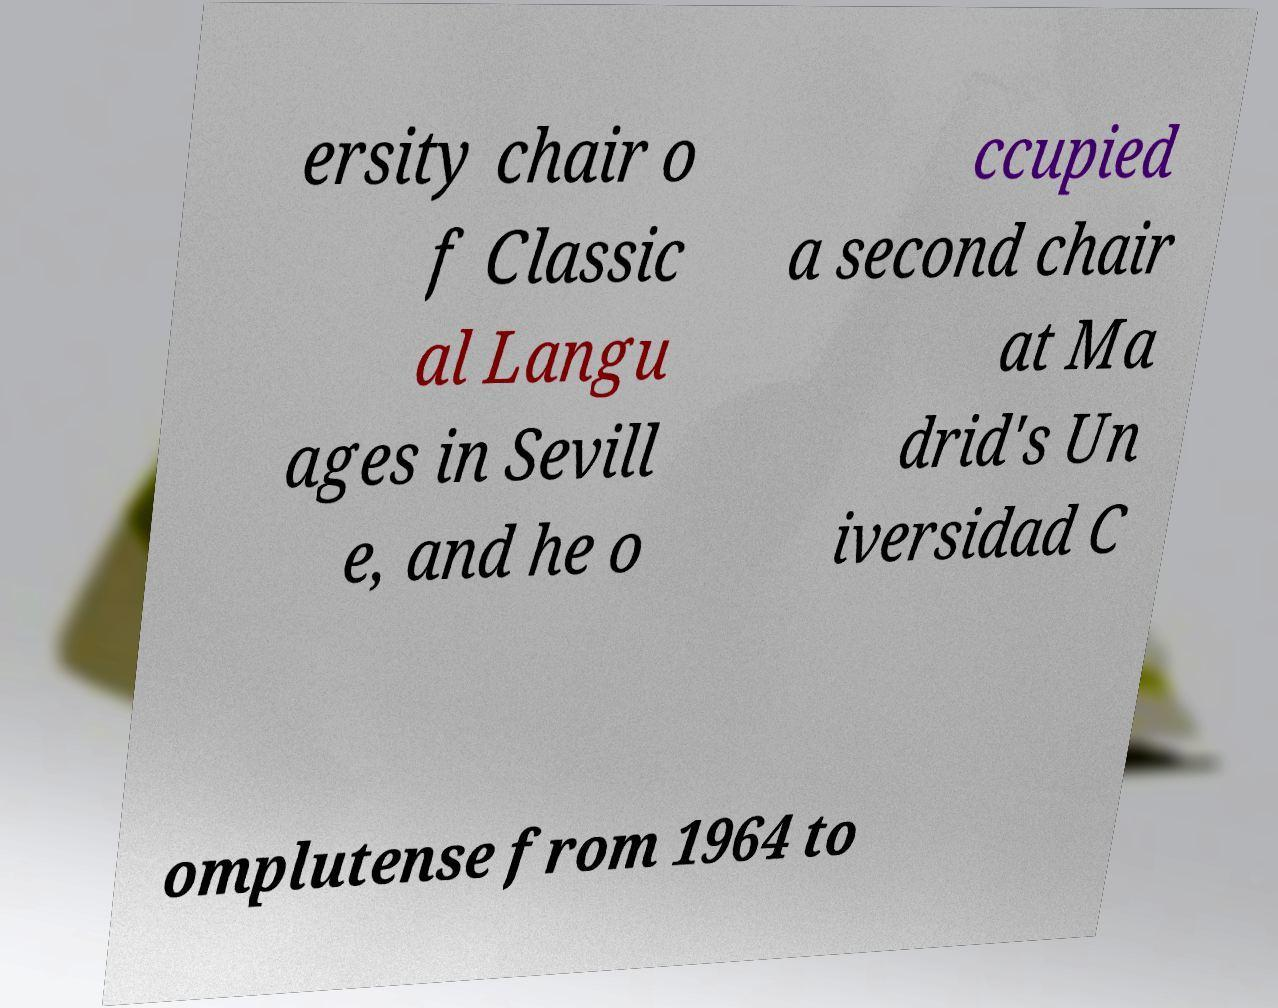Can you accurately transcribe the text from the provided image for me? ersity chair o f Classic al Langu ages in Sevill e, and he o ccupied a second chair at Ma drid's Un iversidad C omplutense from 1964 to 